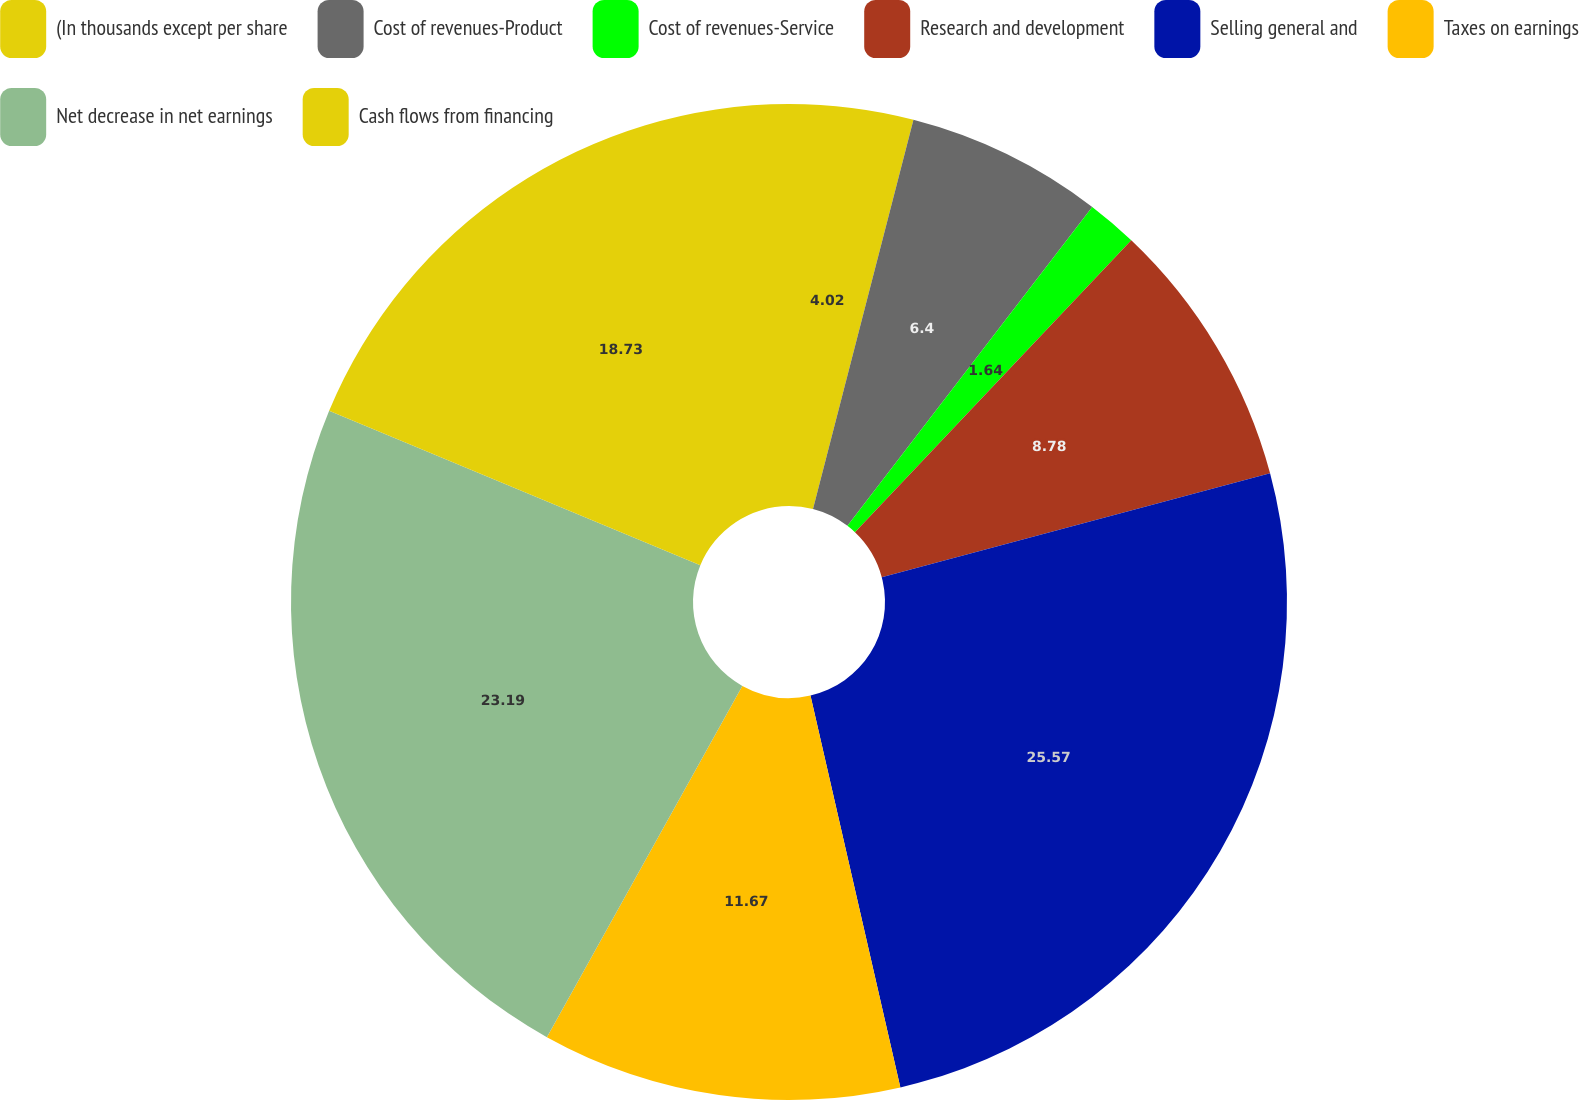Convert chart to OTSL. <chart><loc_0><loc_0><loc_500><loc_500><pie_chart><fcel>(In thousands except per share<fcel>Cost of revenues-Product<fcel>Cost of revenues-Service<fcel>Research and development<fcel>Selling general and<fcel>Taxes on earnings<fcel>Net decrease in net earnings<fcel>Cash flows from financing<nl><fcel>4.02%<fcel>6.4%<fcel>1.64%<fcel>8.78%<fcel>25.57%<fcel>11.67%<fcel>23.19%<fcel>18.73%<nl></chart> 